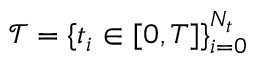Convert formula to latex. <formula><loc_0><loc_0><loc_500><loc_500>\mathcal { T } = \{ t _ { i } \in [ 0 , T ] \} _ { i = 0 } ^ { N _ { t } }</formula> 